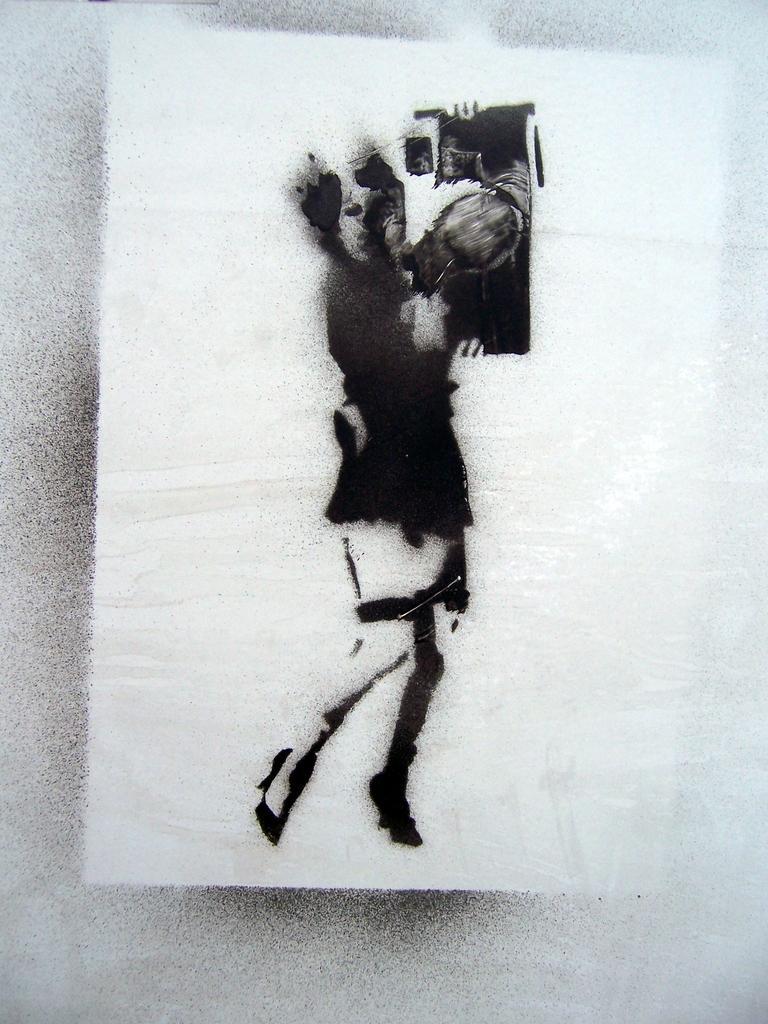In one or two sentences, can you explain what this image depicts? In the center of this picture we can see the drawing of a person holding some objects. In the background we can see the paper. 